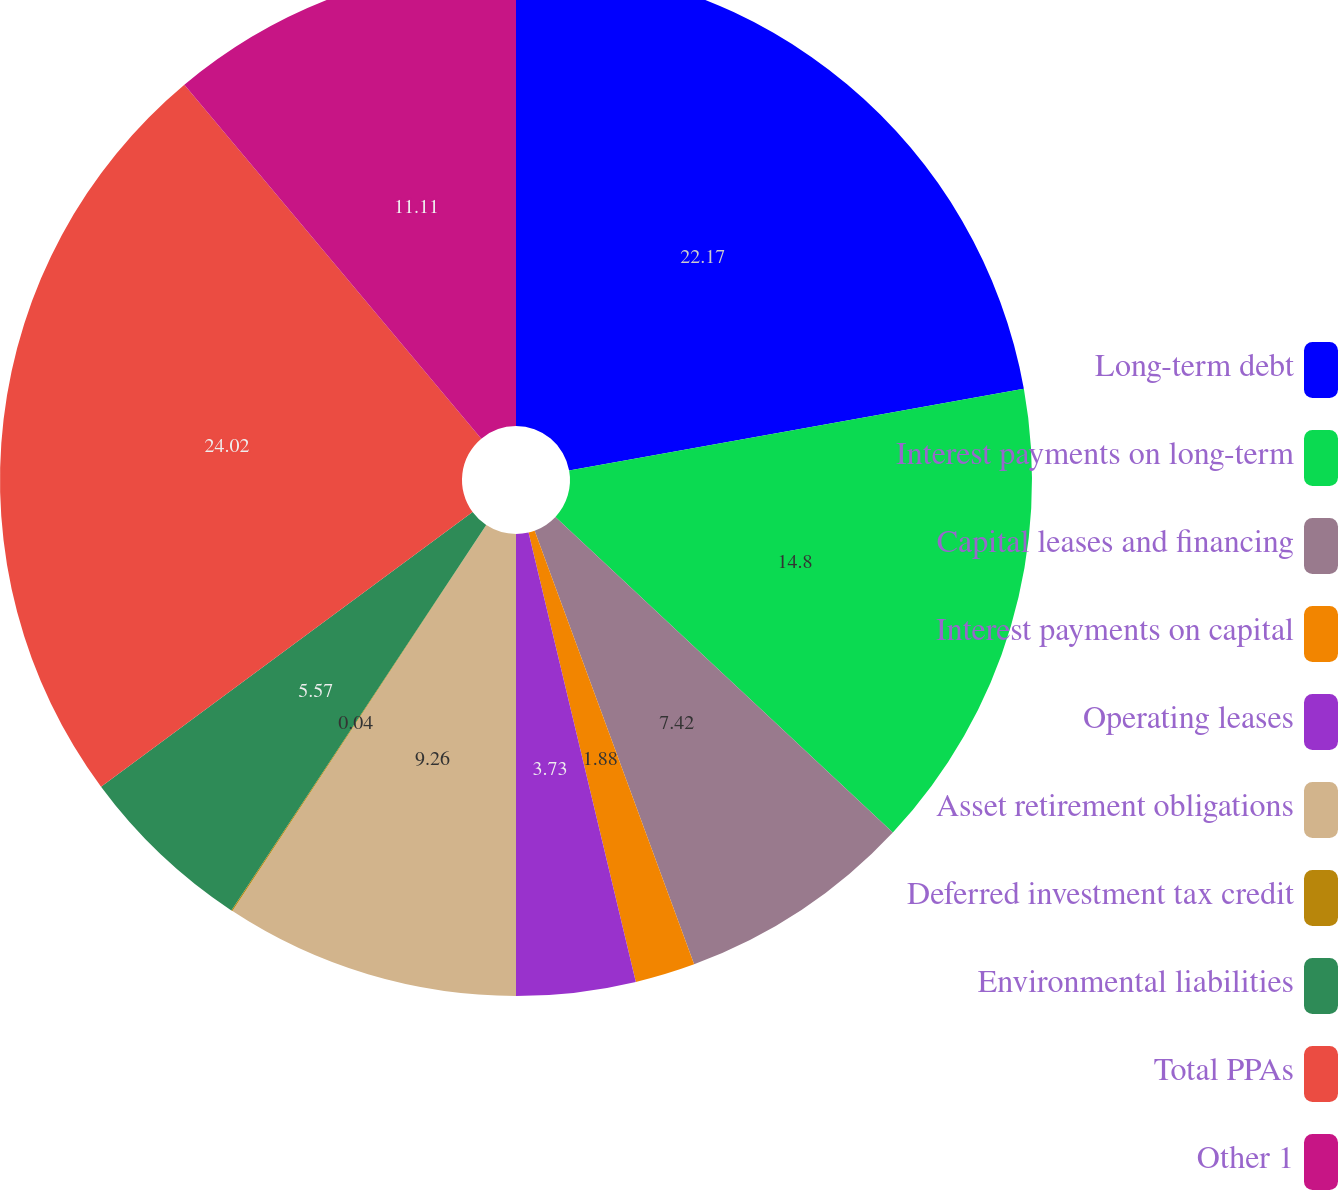Convert chart. <chart><loc_0><loc_0><loc_500><loc_500><pie_chart><fcel>Long-term debt<fcel>Interest payments on long-term<fcel>Capital leases and financing<fcel>Interest payments on capital<fcel>Operating leases<fcel>Asset retirement obligations<fcel>Deferred investment tax credit<fcel>Environmental liabilities<fcel>Total PPAs<fcel>Other 1<nl><fcel>22.17%<fcel>14.8%<fcel>7.42%<fcel>1.88%<fcel>3.73%<fcel>9.26%<fcel>0.04%<fcel>5.57%<fcel>24.02%<fcel>11.11%<nl></chart> 